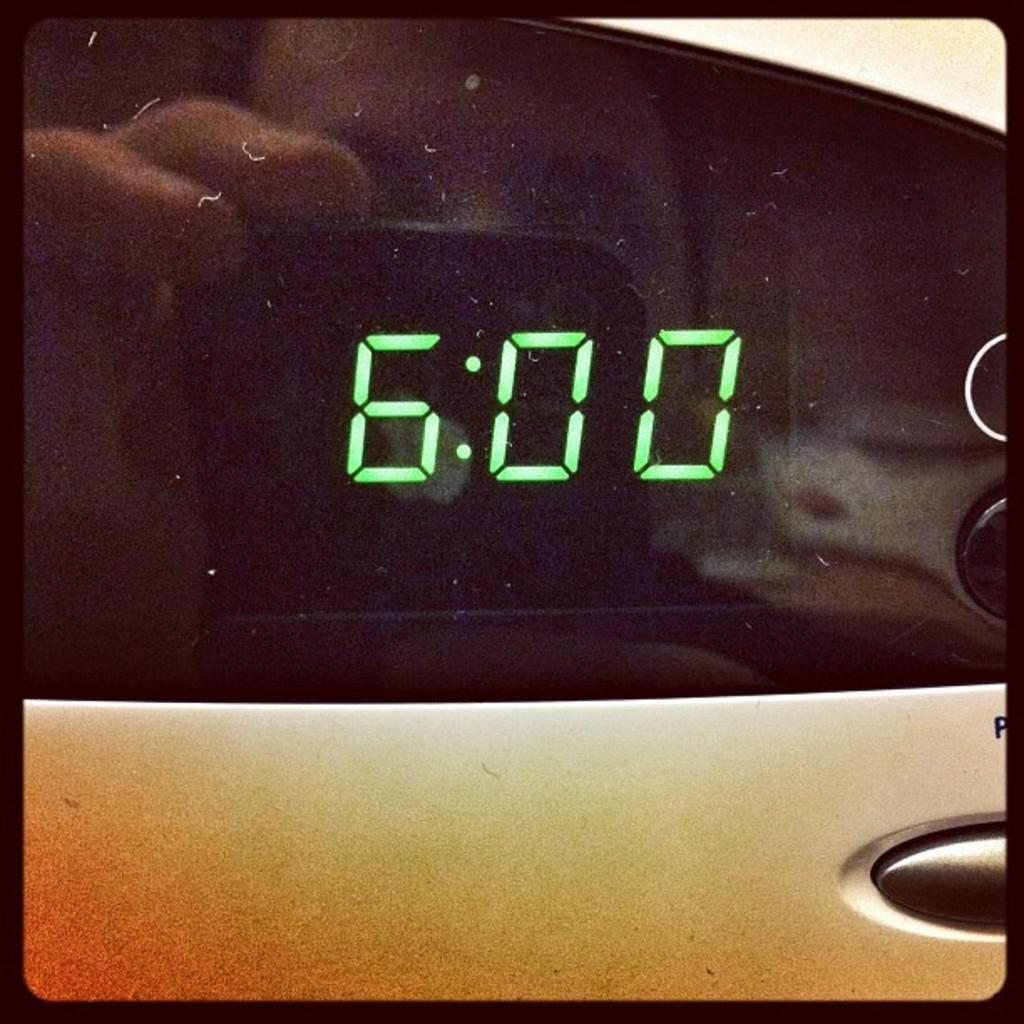<image>
Give a short and clear explanation of the subsequent image. The black clock is showing a time of 6:00. 